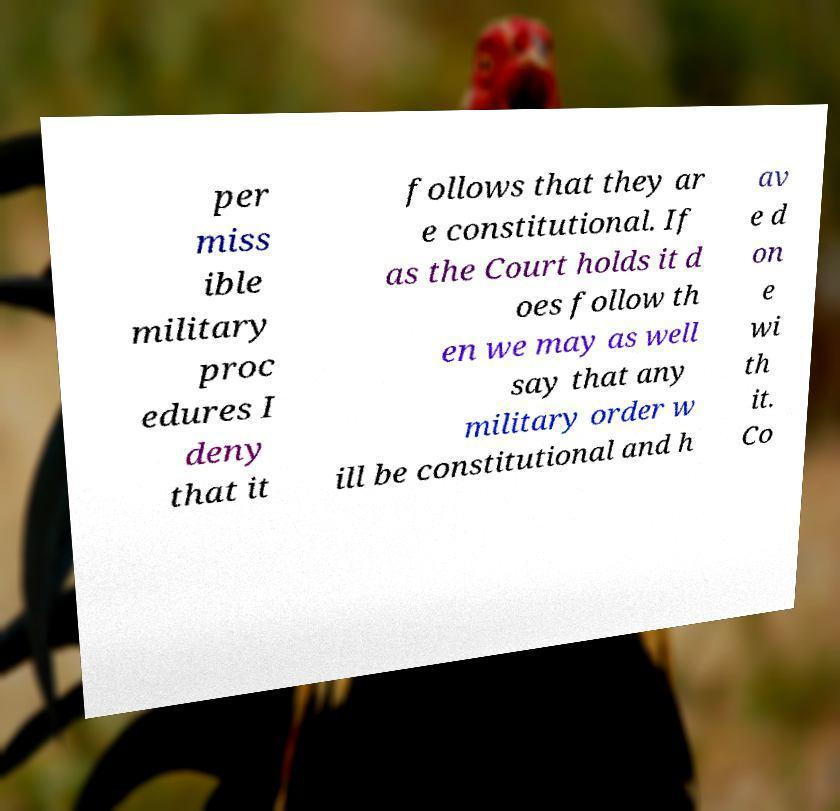For documentation purposes, I need the text within this image transcribed. Could you provide that? per miss ible military proc edures I deny that it follows that they ar e constitutional. If as the Court holds it d oes follow th en we may as well say that any military order w ill be constitutional and h av e d on e wi th it. Co 